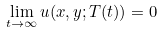Convert formula to latex. <formula><loc_0><loc_0><loc_500><loc_500>\lim _ { t \to \infty } u ( x , y ; T ( t ) ) = 0</formula> 